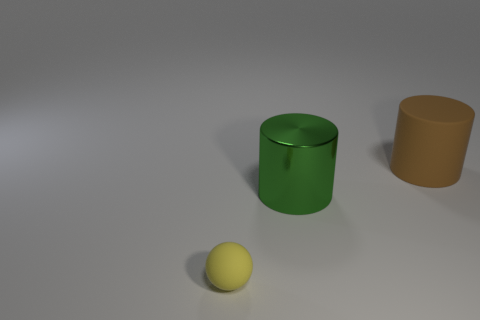Add 1 large purple spheres. How many objects exist? 4 Subtract all balls. How many objects are left? 2 Add 1 big green metallic cylinders. How many big green metallic cylinders exist? 2 Subtract 0 purple cylinders. How many objects are left? 3 Subtract all matte things. Subtract all large rubber things. How many objects are left? 0 Add 1 brown things. How many brown things are left? 2 